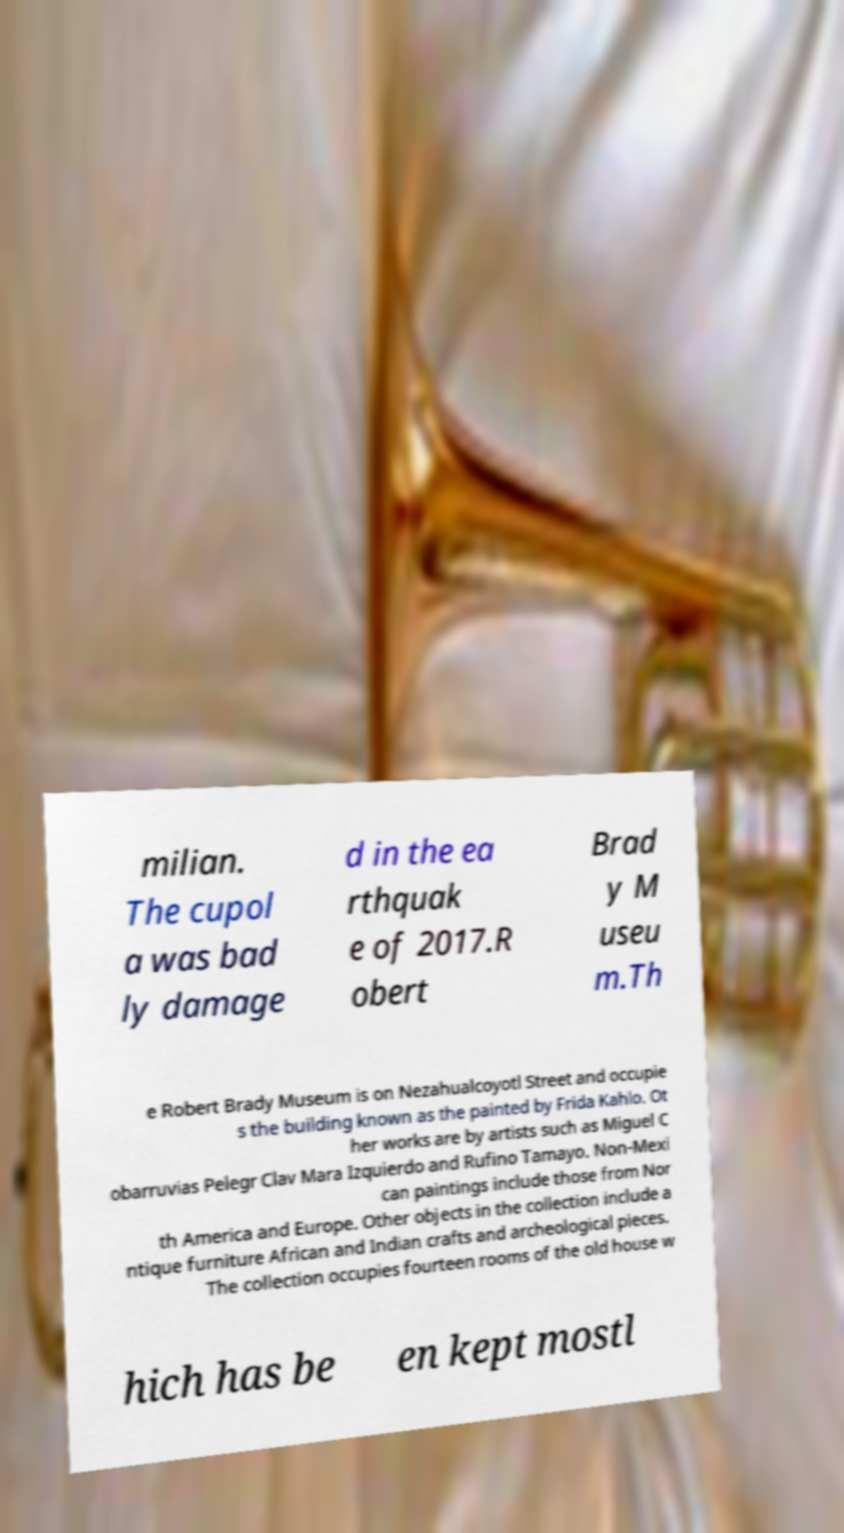What messages or text are displayed in this image? I need them in a readable, typed format. milian. The cupol a was bad ly damage d in the ea rthquak e of 2017.R obert Brad y M useu m.Th e Robert Brady Museum is on Nezahualcoyotl Street and occupie s the building known as the painted by Frida Kahlo. Ot her works are by artists such as Miguel C obarruvias Pelegr Clav Mara Izquierdo and Rufino Tamayo. Non-Mexi can paintings include those from Nor th America and Europe. Other objects in the collection include a ntique furniture African and Indian crafts and archeological pieces. The collection occupies fourteen rooms of the old house w hich has be en kept mostl 